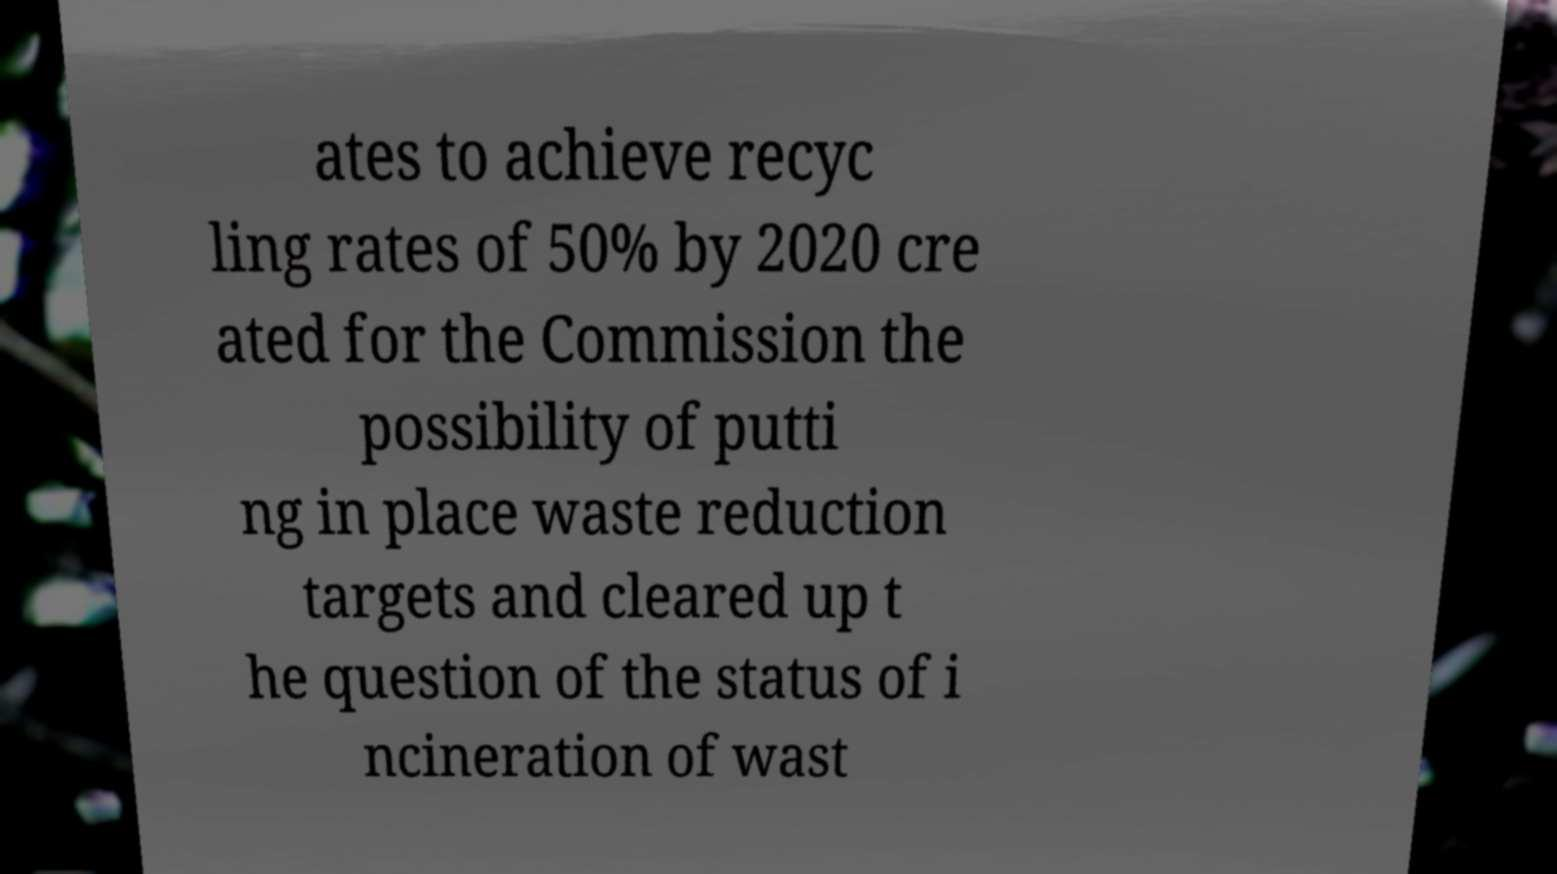What messages or text are displayed in this image? I need them in a readable, typed format. ates to achieve recyc ling rates of 50% by 2020 cre ated for the Commission the possibility of putti ng in place waste reduction targets and cleared up t he question of the status of i ncineration of wast 